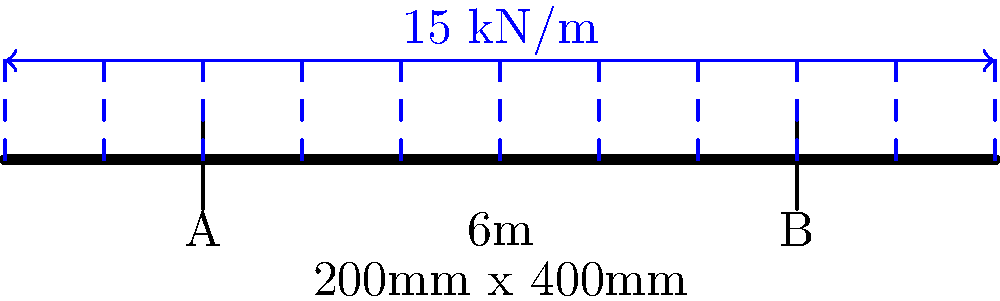As a young and innovative producer working on remastering albums, you've been tasked with designing a stage that can support heavy equipment. Calculate the maximum bending moment in the simply supported beam shown above, which represents a crucial structural element of the stage. The beam has a span of 6m, a cross-section of 200mm x 400mm, and is subjected to a uniformly distributed load of 15 kN/m. Assume the beam is made of steel with a yield strength of 250 MPa. To calculate the maximum bending moment in the simply supported beam, we'll follow these steps:

1. Identify the given information:
   - Span length, $L = 6$ m
   - Uniformly distributed load, $w = 15$ kN/m
   - Cross-section: 200mm x 400mm
   - Steel yield strength: 250 MPa (not needed for this calculation)

2. For a simply supported beam with a uniformly distributed load, the maximum bending moment occurs at the center of the beam and is given by the formula:

   $$ M_{max} = \frac{wL^2}{8} $$

3. Substitute the values into the formula:

   $$ M_{max} = \frac{15 \text{ kN/m} \times (6 \text{ m})^2}{8} $$

4. Calculate the result:

   $$ M_{max} = \frac{15 \times 36}{8} = 67.5 \text{ kN·m} $$

5. Convert the result to N·m for consistency:

   $$ M_{max} = 67.5 \text{ kN·m} \times 1000 \text{ N/kN} = 67,500 \text{ N·m} $$

Therefore, the maximum bending moment in the beam is 67,500 N·m or 67.5 kN·m.
Answer: 67.5 kN·m 